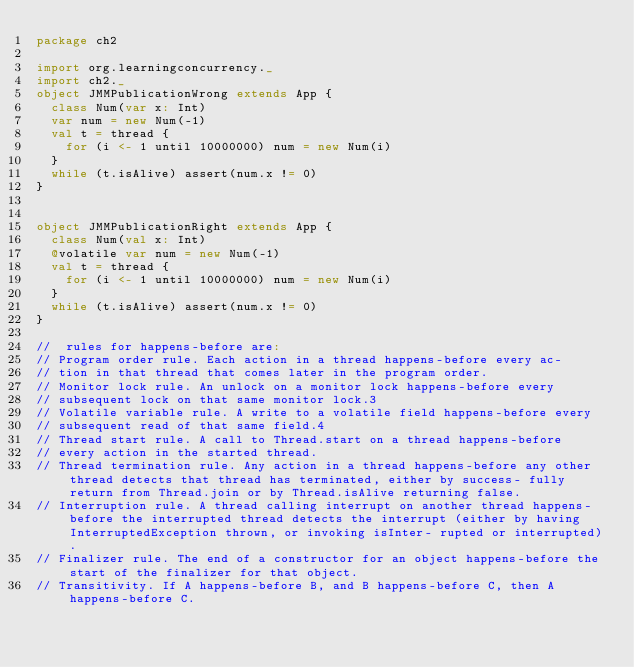<code> <loc_0><loc_0><loc_500><loc_500><_Scala_>package ch2

import org.learningconcurrency._
import ch2._
object JMMPublicationWrong extends App {
  class Num(var x: Int)
  var num = new Num(-1)
  val t = thread {
    for (i <- 1 until 10000000) num = new Num(i)
  }
  while (t.isAlive) assert(num.x != 0)
}


object JMMPublicationRight extends App {
  class Num(val x: Int)
  @volatile var num = new Num(-1)
  val t = thread {
    for (i <- 1 until 10000000) num = new Num(i)
  }
  while (t.isAlive) assert(num.x != 0)
}

//  rules for happens-before are:
// Program order rule. Each action in a thread happens-before every ac-
// tion in that thread that comes later in the program order.
// Monitor lock rule. An unlock on a monitor lock happens-before every
// subsequent lock on that same monitor lock.3
// Volatile variable rule. A write to a volatile field happens-before every
// subsequent read of that same field.4
// Thread start rule. A call to Thread.start on a thread happens-before
// every action in the started thread.
// Thread termination rule. Any action in a thread happens-before any other thread detects that thread has terminated, either by success- fully return from Thread.join or by Thread.isAlive returning false.
// Interruption rule. A thread calling interrupt on another thread happens-before the interrupted thread detects the interrupt (either by having InterruptedException thrown, or invoking isInter- rupted or interrupted).
// Finalizer rule. The end of a constructor for an object happens-before the start of the finalizer for that object.
// Transitivity. If A happens-before B, and B happens-before C, then A happens-before C.


</code> 